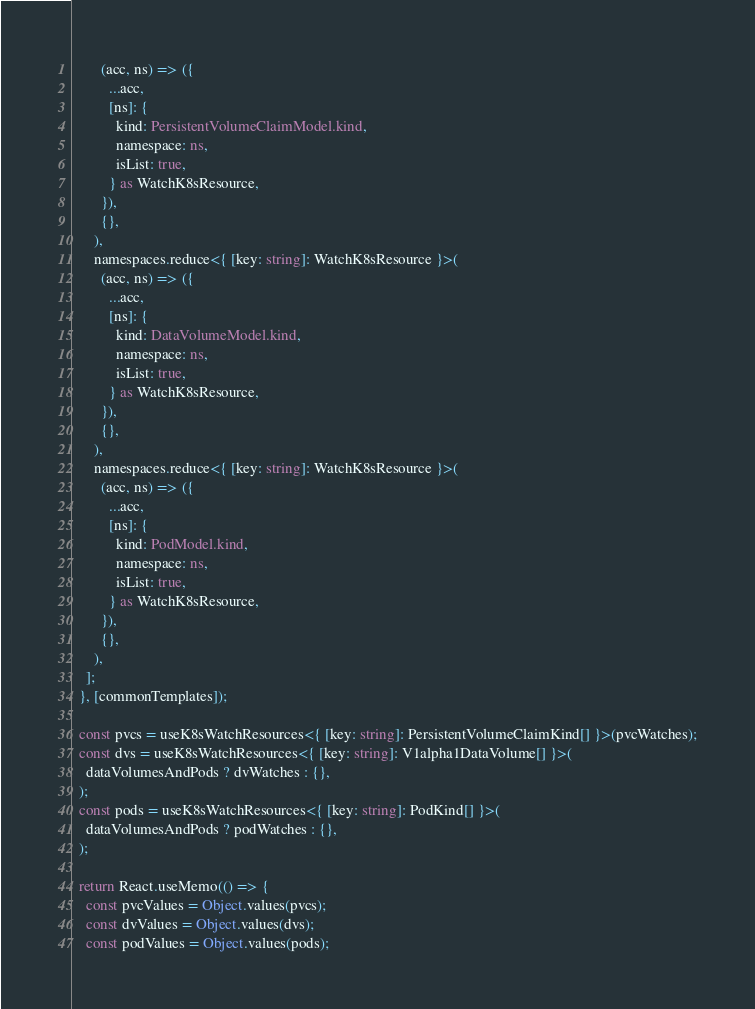<code> <loc_0><loc_0><loc_500><loc_500><_TypeScript_>        (acc, ns) => ({
          ...acc,
          [ns]: {
            kind: PersistentVolumeClaimModel.kind,
            namespace: ns,
            isList: true,
          } as WatchK8sResource,
        }),
        {},
      ),
      namespaces.reduce<{ [key: string]: WatchK8sResource }>(
        (acc, ns) => ({
          ...acc,
          [ns]: {
            kind: DataVolumeModel.kind,
            namespace: ns,
            isList: true,
          } as WatchK8sResource,
        }),
        {},
      ),
      namespaces.reduce<{ [key: string]: WatchK8sResource }>(
        (acc, ns) => ({
          ...acc,
          [ns]: {
            kind: PodModel.kind,
            namespace: ns,
            isList: true,
          } as WatchK8sResource,
        }),
        {},
      ),
    ];
  }, [commonTemplates]);

  const pvcs = useK8sWatchResources<{ [key: string]: PersistentVolumeClaimKind[] }>(pvcWatches);
  const dvs = useK8sWatchResources<{ [key: string]: V1alpha1DataVolume[] }>(
    dataVolumesAndPods ? dvWatches : {},
  );
  const pods = useK8sWatchResources<{ [key: string]: PodKind[] }>(
    dataVolumesAndPods ? podWatches : {},
  );

  return React.useMemo(() => {
    const pvcValues = Object.values(pvcs);
    const dvValues = Object.values(dvs);
    const podValues = Object.values(pods);
</code> 